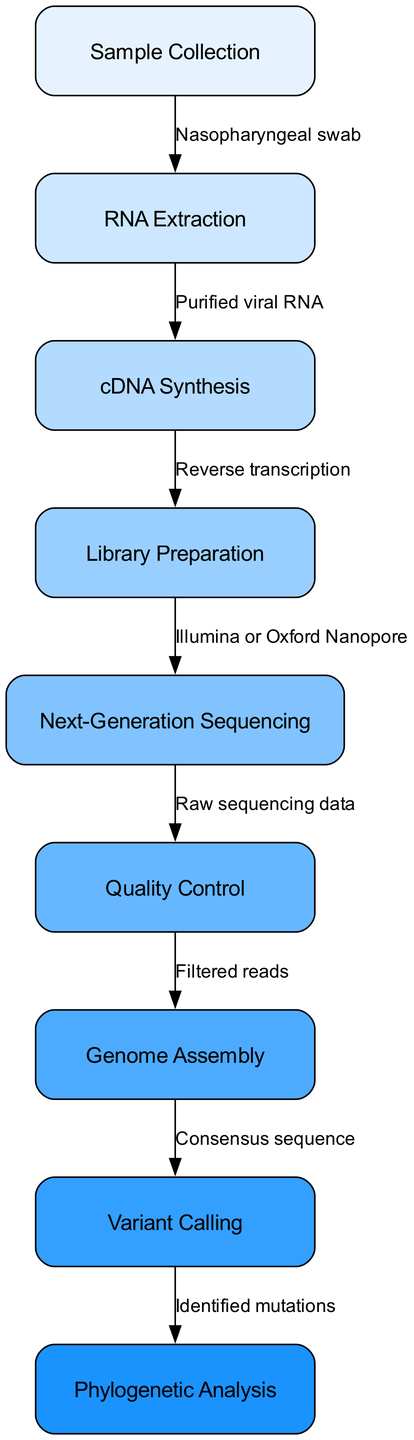What is the first step in the viral genome sequencing process? The first step in the flowchart is labeled "Sample Collection," indicating that this is where the process begins.
Answer: Sample Collection How many nodes are in the diagram? By counting the nodes listed in the data, there are a total of nine distinct steps in the viral genome sequencing process.
Answer: 9 Which step comes after RNA Extraction? According to the flowchart, the step that follows "RNA Extraction" is "cDNA Synthesis," which is directly linked to RNA Extraction in the sequence.
Answer: cDNA Synthesis What type of sequencing method is used in the "Next-Generation Sequencing" step? The flowchart specifies that "Illumina or Oxford Nanopore" are the sequencing methods indicated in the "Library Preparation" connection to "Next-Generation Sequencing."
Answer: Illumina or Oxford Nanopore What is the output of the "Variant Calling" step? From the diagram, the output of the "Variant Calling" step is referred to as "Identified mutations," showing what is produced from this stage of analysis.
Answer: Identified mutations How does "Quality Control" relate to "Next-Generation Sequencing"? The diagram shows a direct flow from "Next-Generation Sequencing" to "Quality Control," indicating that raw sequencing data is processed for quality assurance before further analysis.
Answer: Raw sequencing data Which steps are directly connected by the edge labeled "Reverse transcription"? The edge labeled "Reverse transcription" connects "cDNA Synthesis" to "Library Preparation," indicating these two steps are sequentially linked in the process.
Answer: cDNA Synthesis to Library Preparation What is the final analysis step in the flowchart? The last step in the flowchart is "Phylogenetic Analysis," which indicates that this is the culmination of the previous steps focused on data analysis.
Answer: Phylogenetic Analysis How many edges are there between the nodes in the diagram? By counting the connections between the nodes, there are a total of eight edges defined in the data, illustrating the flow of the process.
Answer: 8 